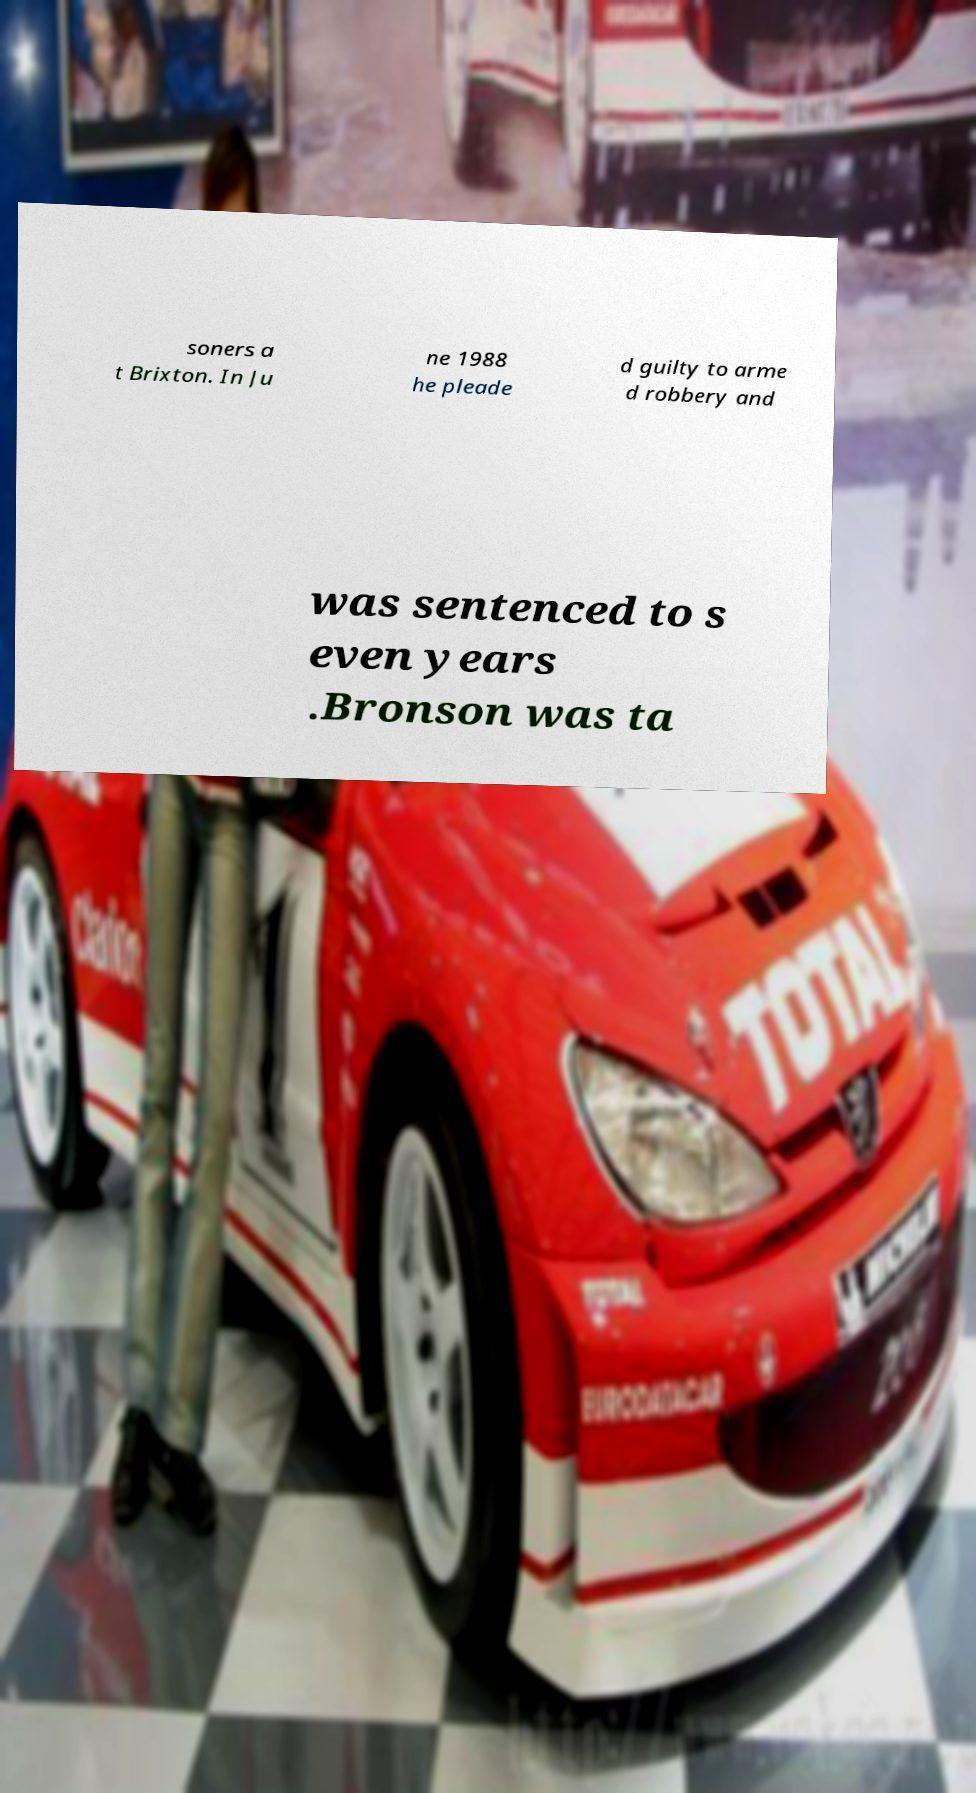Can you accurately transcribe the text from the provided image for me? soners a t Brixton. In Ju ne 1988 he pleade d guilty to arme d robbery and was sentenced to s even years .Bronson was ta 